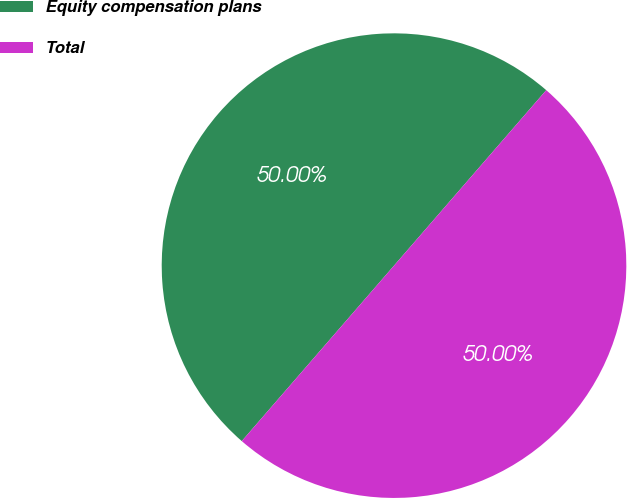<chart> <loc_0><loc_0><loc_500><loc_500><pie_chart><fcel>Equity compensation plans<fcel>Total<nl><fcel>50.0%<fcel>50.0%<nl></chart> 